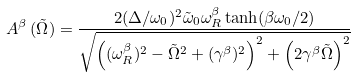<formula> <loc_0><loc_0><loc_500><loc_500>A ^ { \beta } \, ( \tilde { \Omega } ) = \frac { 2 ( \Delta / \omega _ { 0 } ) ^ { 2 } \tilde { \omega } _ { 0 } \omega _ { R } ^ { \beta } \tanh ( \beta \omega _ { 0 } / 2 ) } { \sqrt { \left ( ( \omega _ { R } ^ { \beta } ) ^ { 2 } - \tilde { \Omega } ^ { 2 } + ( \gamma ^ { \beta } ) ^ { 2 } \right ) ^ { 2 } + \left ( 2 \gamma ^ { \beta } \tilde { \Omega } \right ) ^ { 2 } } }</formula> 